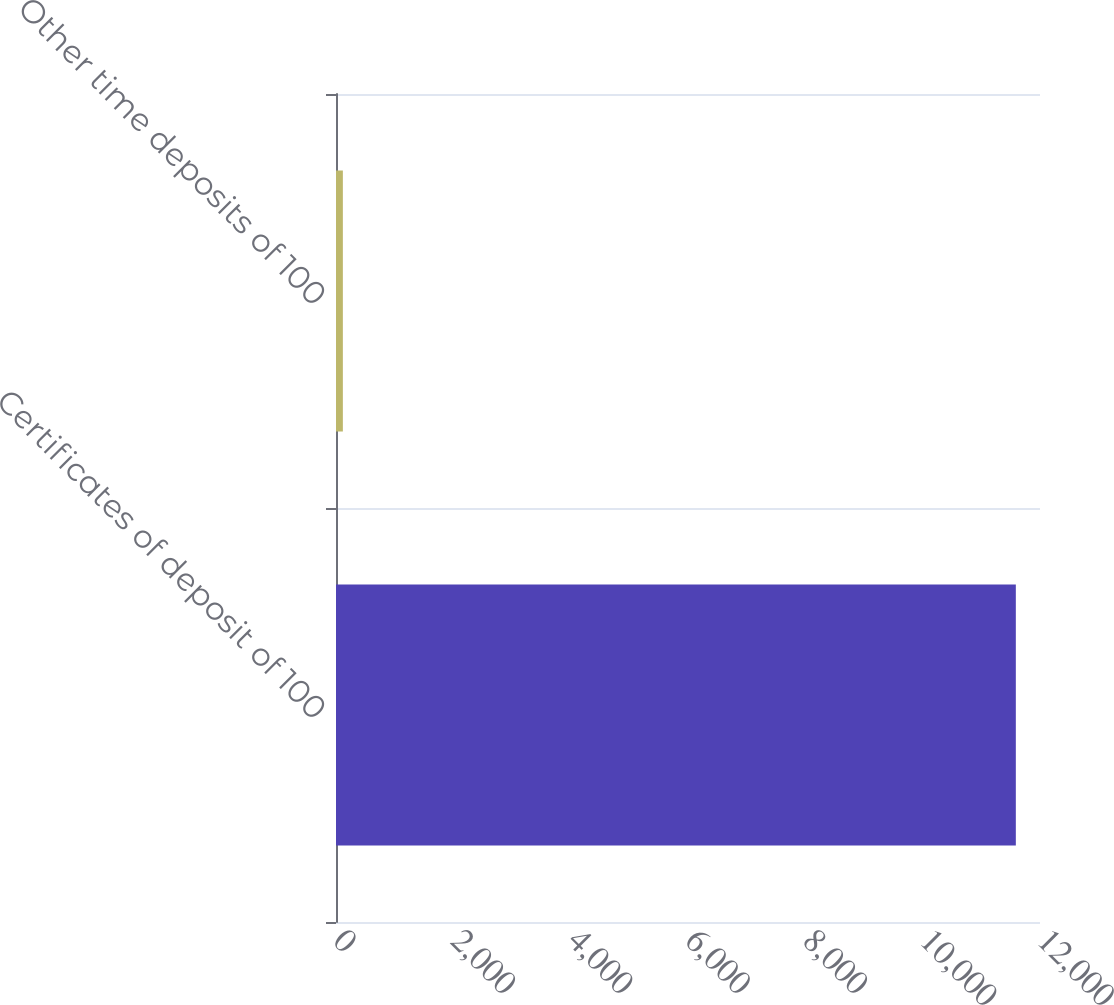<chart> <loc_0><loc_0><loc_500><loc_500><bar_chart><fcel>Certificates of deposit of 100<fcel>Other time deposits of 100<nl><fcel>11588<fcel>117<nl></chart> 